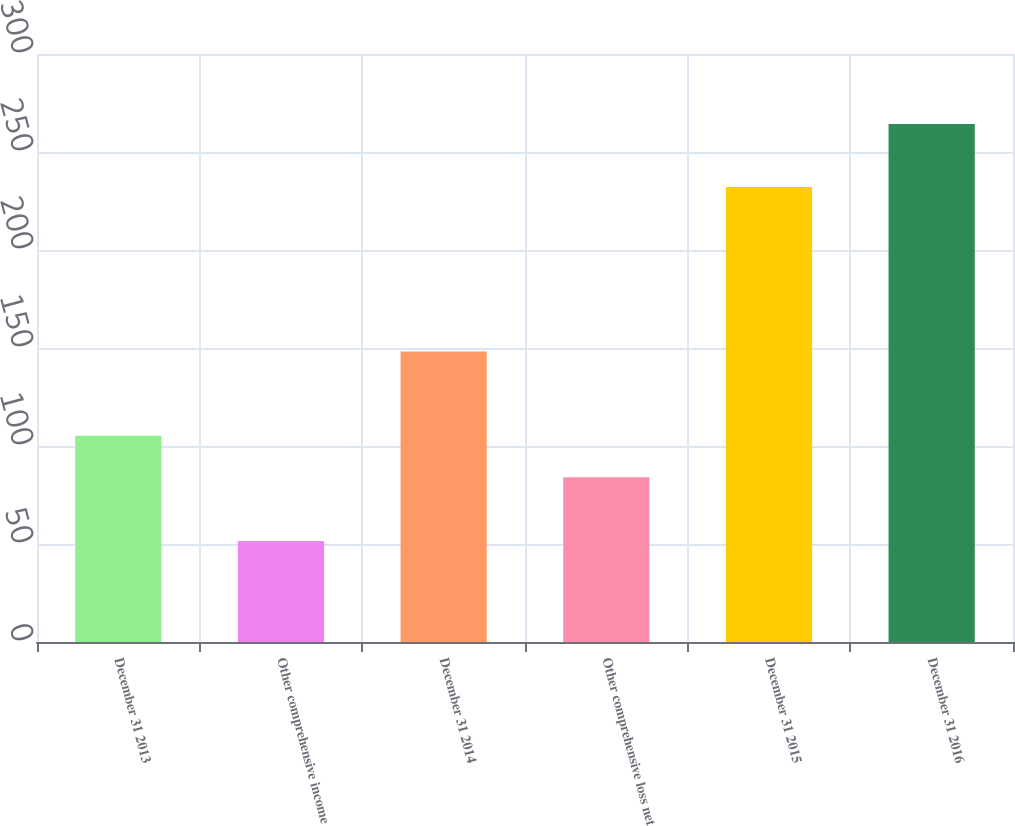Convert chart. <chart><loc_0><loc_0><loc_500><loc_500><bar_chart><fcel>December 31 2013<fcel>Other comprehensive income<fcel>December 31 2014<fcel>Other comprehensive loss net<fcel>December 31 2015<fcel>December 31 2016<nl><fcel>105.28<fcel>51.5<fcel>148.2<fcel>84<fcel>232.2<fcel>264.3<nl></chart> 